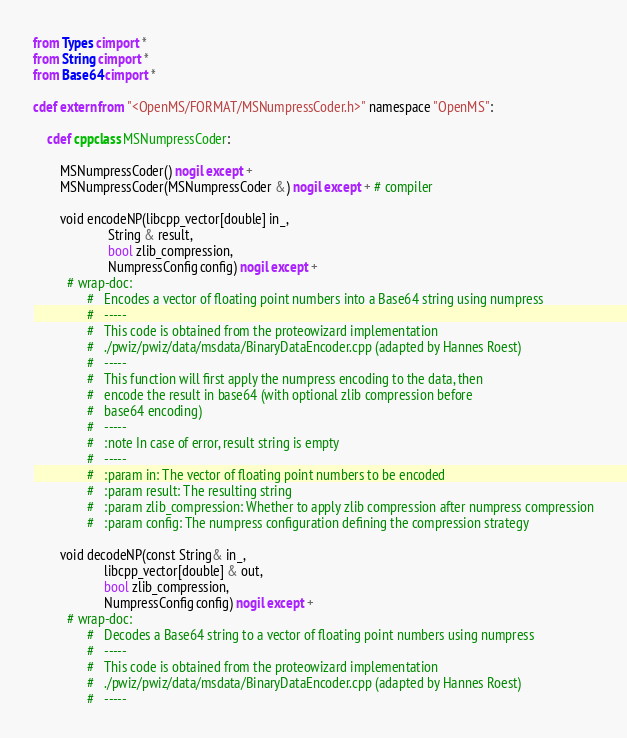Convert code to text. <code><loc_0><loc_0><loc_500><loc_500><_Cython_>from Types cimport *
from String cimport *
from Base64 cimport *

cdef extern from "<OpenMS/FORMAT/MSNumpressCoder.h>" namespace "OpenMS":

    cdef cppclass MSNumpressCoder:

        MSNumpressCoder() nogil except +
        MSNumpressCoder(MSNumpressCoder &) nogil except + # compiler

        void encodeNP(libcpp_vector[double] in_,
                      String & result,
                      bool zlib_compression,
                      NumpressConfig config) nogil except +
          # wrap-doc:
                #   Encodes a vector of floating point numbers into a Base64 string using numpress
                #   -----
                #   This code is obtained from the proteowizard implementation
                #   ./pwiz/pwiz/data/msdata/BinaryDataEncoder.cpp (adapted by Hannes Roest)
                #   -----
                #   This function will first apply the numpress encoding to the data, then
                #   encode the result in base64 (with optional zlib compression before
                #   base64 encoding)
                #   -----
                #   :note In case of error, result string is empty
                #   -----
                #   :param in: The vector of floating point numbers to be encoded
                #   :param result: The resulting string
                #   :param zlib_compression: Whether to apply zlib compression after numpress compression
                #   :param config: The numpress configuration defining the compression strategy

        void decodeNP(const String& in_,
                     libcpp_vector[double] & out,
                     bool zlib_compression,
                     NumpressConfig config) nogil except +
          # wrap-doc:
                #   Decodes a Base64 string to a vector of floating point numbers using numpress
                #   -----
                #   This code is obtained from the proteowizard implementation
                #   ./pwiz/pwiz/data/msdata/BinaryDataEncoder.cpp (adapted by Hannes Roest)
                #   -----</code> 